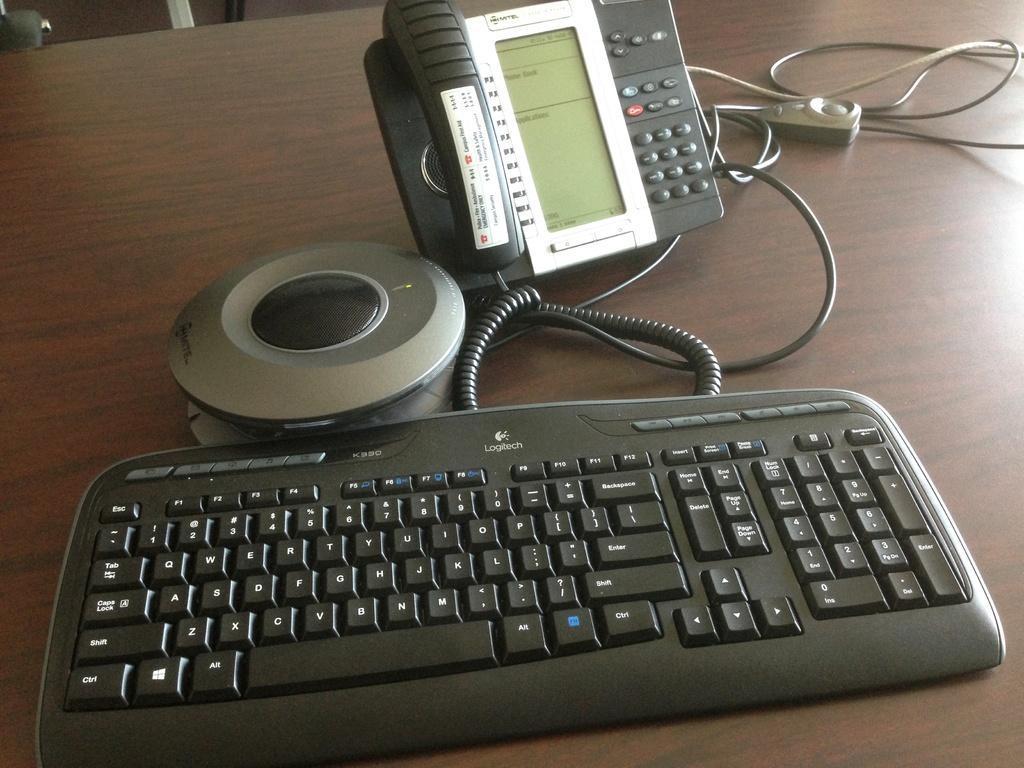Can you describe this image briefly? In this picture we can see a keyboard, a telephone, wires and an object on the table. We can see other objects. 